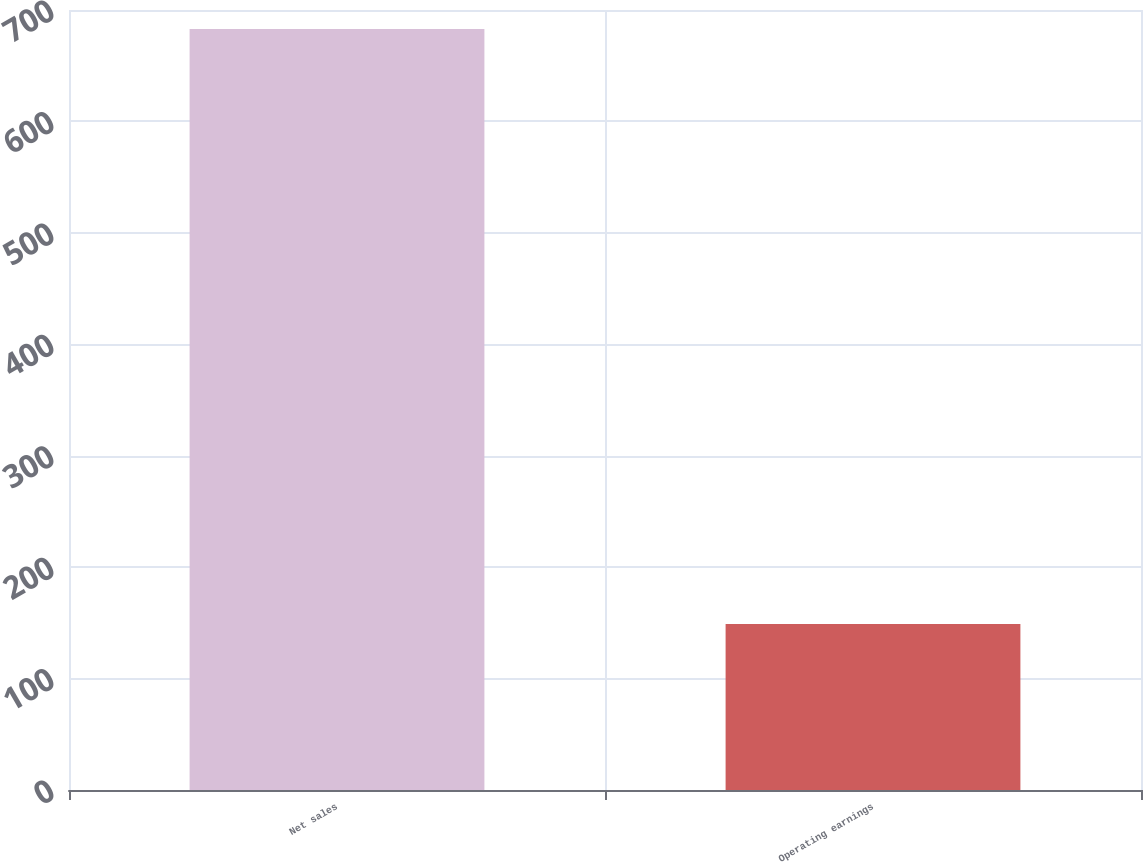Convert chart to OTSL. <chart><loc_0><loc_0><loc_500><loc_500><bar_chart><fcel>Net sales<fcel>Operating earnings<nl><fcel>683<fcel>149<nl></chart> 